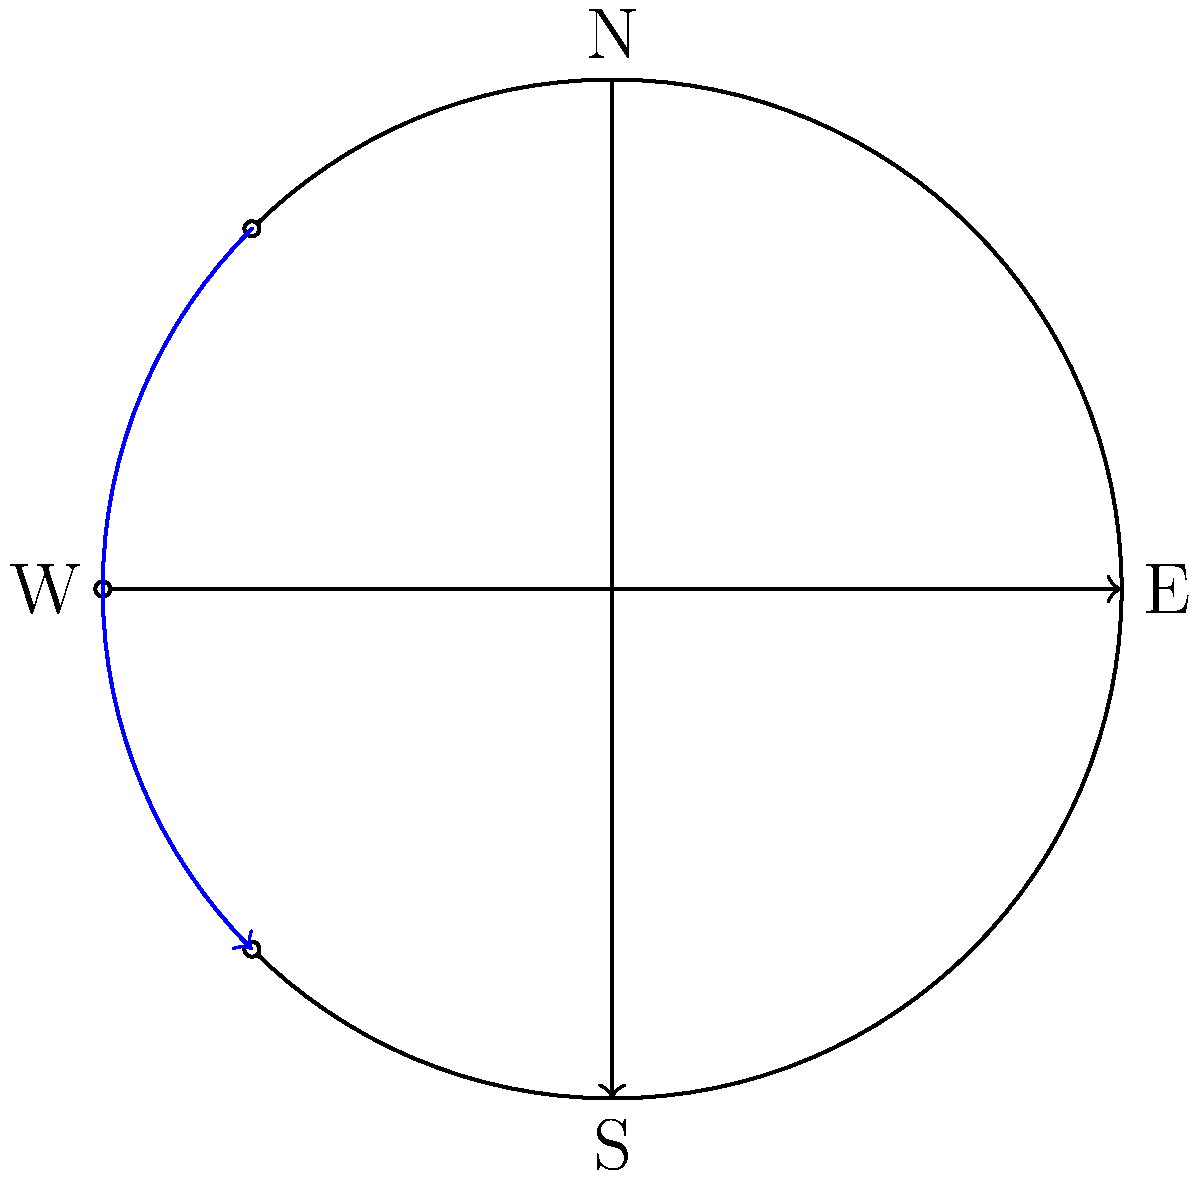As a senior writer drawing inspiration from real-life observations, you're crafting a scene set under the night sky. How would you describe the apparent motion of stars throughout the night to create a vivid and scientifically accurate backdrop for your characters? To accurately describe the apparent motion of stars in the night sky, consider the following steps:

1. Earth's rotation: The Earth rotates on its axis from west to east, completing one full rotation in approximately 24 hours.

2. Observer's perspective: From our vantage point on Earth, this rotation makes the stars appear to move in the opposite direction, from east to west.

3. Celestial sphere: Imagine the stars fixed on a giant celestial sphere surrounding Earth. As Earth rotates, this sphere appears to rotate around us.

4. Axis of rotation: The stars appear to rotate around the celestial poles, which are the points where Earth's axis of rotation intersects the celestial sphere.

5. Circumpolar stars: Stars near the celestial pole (determined by the observer's latitude) will appear to circle the pole without setting below the horizon. These are called circumpolar stars.

6. Rising and setting: Most stars will appear to rise in the east, arc across the sky, and set in the west.

7. Angular velocity: The stars complete one full rotation in 23 hours and 56 minutes (a sidereal day), moving at an angular velocity of approximately $\frac{360°}{24 \text{ hours}} = 15°$ per hour.

8. Star trails: In long-exposure photographs or to the naked eye over time, stars leave circular trails centered on the celestial pole.

9. Seasonal changes: The position of stars at a given time of night changes gradually throughout the year due to Earth's orbit around the Sun.

To incorporate this into your writing, you might describe the slow, majestic wheeling of the stars overhead, with some stars circling endlessly around a fixed point (the celestial pole), while others rise and set. You could mention how the positions of familiar constellations shift throughout the night, or how the stars seem to rotate around a character as they lie on their back, gazing upward.
Answer: Stars appear to rotate from east to west around the celestial pole due to Earth's rotation. 